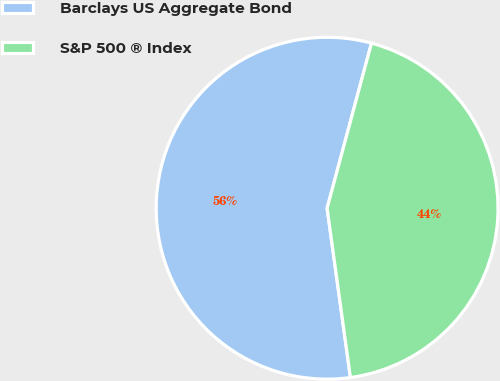Convert chart. <chart><loc_0><loc_0><loc_500><loc_500><pie_chart><fcel>Barclays US Aggregate Bond<fcel>S&P 500 ® Index<nl><fcel>56.36%<fcel>43.64%<nl></chart> 